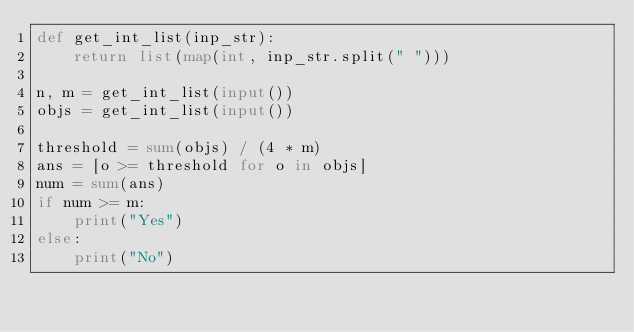Convert code to text. <code><loc_0><loc_0><loc_500><loc_500><_Python_>def get_int_list(inp_str):
    return list(map(int, inp_str.split(" ")))

n, m = get_int_list(input())
objs = get_int_list(input())

threshold = sum(objs) / (4 * m)
ans = [o >= threshold for o in objs]
num = sum(ans)
if num >= m:
    print("Yes")
else:
    print("No")


</code> 